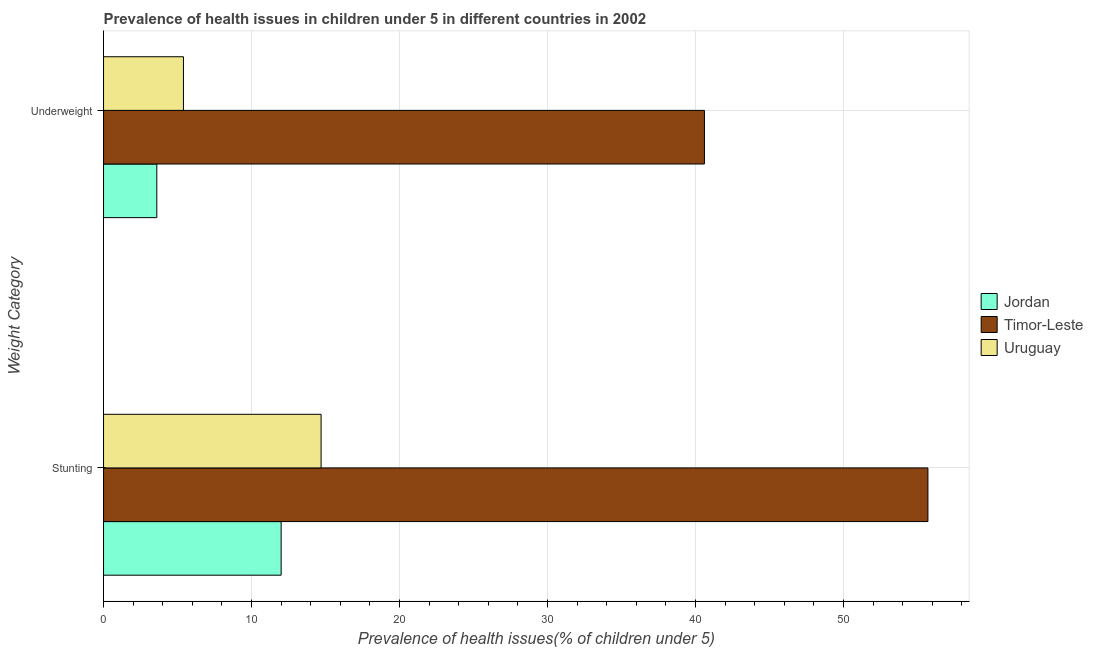How many groups of bars are there?
Give a very brief answer. 2. What is the label of the 2nd group of bars from the top?
Your response must be concise. Stunting. What is the percentage of stunted children in Timor-Leste?
Your answer should be very brief. 55.7. Across all countries, what is the maximum percentage of stunted children?
Keep it short and to the point. 55.7. Across all countries, what is the minimum percentage of underweight children?
Your answer should be very brief. 3.6. In which country was the percentage of stunted children maximum?
Provide a short and direct response. Timor-Leste. In which country was the percentage of stunted children minimum?
Make the answer very short. Jordan. What is the total percentage of stunted children in the graph?
Your answer should be compact. 82.4. What is the difference between the percentage of underweight children in Uruguay and that in Jordan?
Your answer should be very brief. 1.8. What is the difference between the percentage of underweight children in Jordan and the percentage of stunted children in Uruguay?
Your answer should be very brief. -11.1. What is the average percentage of underweight children per country?
Offer a very short reply. 16.53. What is the difference between the percentage of underweight children and percentage of stunted children in Uruguay?
Make the answer very short. -9.3. In how many countries, is the percentage of underweight children greater than 46 %?
Make the answer very short. 0. What is the ratio of the percentage of stunted children in Jordan to that in Uruguay?
Keep it short and to the point. 0.82. In how many countries, is the percentage of stunted children greater than the average percentage of stunted children taken over all countries?
Offer a terse response. 1. What does the 1st bar from the top in Underweight represents?
Provide a short and direct response. Uruguay. What does the 3rd bar from the bottom in Underweight represents?
Provide a short and direct response. Uruguay. What is the difference between two consecutive major ticks on the X-axis?
Your answer should be compact. 10. Does the graph contain any zero values?
Your answer should be compact. No. Where does the legend appear in the graph?
Provide a short and direct response. Center right. How many legend labels are there?
Ensure brevity in your answer.  3. How are the legend labels stacked?
Make the answer very short. Vertical. What is the title of the graph?
Provide a succinct answer. Prevalence of health issues in children under 5 in different countries in 2002. Does "Oman" appear as one of the legend labels in the graph?
Make the answer very short. No. What is the label or title of the X-axis?
Offer a very short reply. Prevalence of health issues(% of children under 5). What is the label or title of the Y-axis?
Offer a very short reply. Weight Category. What is the Prevalence of health issues(% of children under 5) in Timor-Leste in Stunting?
Your response must be concise. 55.7. What is the Prevalence of health issues(% of children under 5) of Uruguay in Stunting?
Your answer should be very brief. 14.7. What is the Prevalence of health issues(% of children under 5) in Jordan in Underweight?
Offer a very short reply. 3.6. What is the Prevalence of health issues(% of children under 5) of Timor-Leste in Underweight?
Keep it short and to the point. 40.6. What is the Prevalence of health issues(% of children under 5) of Uruguay in Underweight?
Ensure brevity in your answer.  5.4. Across all Weight Category, what is the maximum Prevalence of health issues(% of children under 5) of Jordan?
Provide a succinct answer. 12. Across all Weight Category, what is the maximum Prevalence of health issues(% of children under 5) of Timor-Leste?
Your answer should be very brief. 55.7. Across all Weight Category, what is the maximum Prevalence of health issues(% of children under 5) in Uruguay?
Provide a succinct answer. 14.7. Across all Weight Category, what is the minimum Prevalence of health issues(% of children under 5) in Jordan?
Provide a succinct answer. 3.6. Across all Weight Category, what is the minimum Prevalence of health issues(% of children under 5) of Timor-Leste?
Provide a succinct answer. 40.6. Across all Weight Category, what is the minimum Prevalence of health issues(% of children under 5) of Uruguay?
Provide a succinct answer. 5.4. What is the total Prevalence of health issues(% of children under 5) of Timor-Leste in the graph?
Your answer should be very brief. 96.3. What is the total Prevalence of health issues(% of children under 5) of Uruguay in the graph?
Your response must be concise. 20.1. What is the difference between the Prevalence of health issues(% of children under 5) in Timor-Leste in Stunting and that in Underweight?
Provide a short and direct response. 15.1. What is the difference between the Prevalence of health issues(% of children under 5) in Jordan in Stunting and the Prevalence of health issues(% of children under 5) in Timor-Leste in Underweight?
Offer a terse response. -28.6. What is the difference between the Prevalence of health issues(% of children under 5) of Timor-Leste in Stunting and the Prevalence of health issues(% of children under 5) of Uruguay in Underweight?
Your answer should be compact. 50.3. What is the average Prevalence of health issues(% of children under 5) in Timor-Leste per Weight Category?
Your answer should be compact. 48.15. What is the average Prevalence of health issues(% of children under 5) in Uruguay per Weight Category?
Your answer should be compact. 10.05. What is the difference between the Prevalence of health issues(% of children under 5) of Jordan and Prevalence of health issues(% of children under 5) of Timor-Leste in Stunting?
Provide a short and direct response. -43.7. What is the difference between the Prevalence of health issues(% of children under 5) in Jordan and Prevalence of health issues(% of children under 5) in Uruguay in Stunting?
Provide a succinct answer. -2.7. What is the difference between the Prevalence of health issues(% of children under 5) in Jordan and Prevalence of health issues(% of children under 5) in Timor-Leste in Underweight?
Keep it short and to the point. -37. What is the difference between the Prevalence of health issues(% of children under 5) in Timor-Leste and Prevalence of health issues(% of children under 5) in Uruguay in Underweight?
Your answer should be compact. 35.2. What is the ratio of the Prevalence of health issues(% of children under 5) in Jordan in Stunting to that in Underweight?
Offer a very short reply. 3.33. What is the ratio of the Prevalence of health issues(% of children under 5) in Timor-Leste in Stunting to that in Underweight?
Provide a short and direct response. 1.37. What is the ratio of the Prevalence of health issues(% of children under 5) in Uruguay in Stunting to that in Underweight?
Your answer should be very brief. 2.72. 